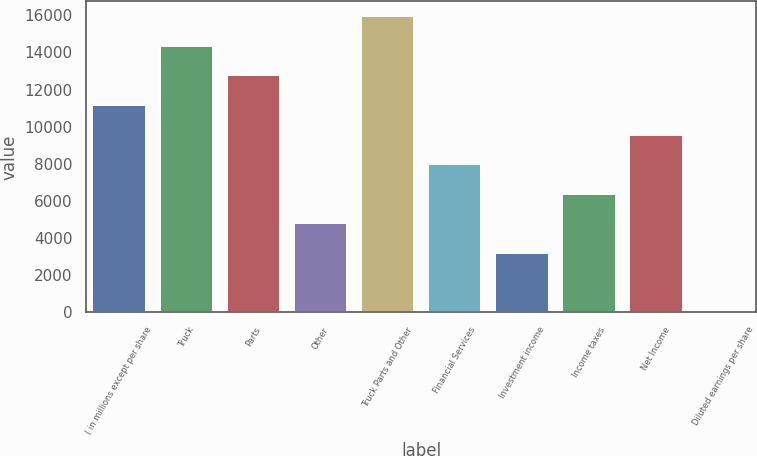Convert chart. <chart><loc_0><loc_0><loc_500><loc_500><bar_chart><fcel>( in millions except per share<fcel>Truck<fcel>Parts<fcel>Other<fcel>Truck Parts and Other<fcel>Financial Services<fcel>Investment income<fcel>Income taxes<fcel>Net Income<fcel>Diluted earnings per share<nl><fcel>11167.1<fcel>14356.9<fcel>12762<fcel>4787.7<fcel>15951.7<fcel>7977.42<fcel>3192.84<fcel>6382.56<fcel>9572.28<fcel>3.12<nl></chart> 